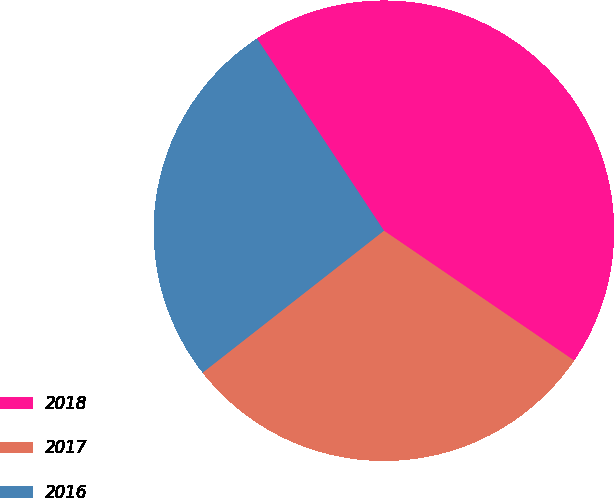Convert chart. <chart><loc_0><loc_0><loc_500><loc_500><pie_chart><fcel>2018<fcel>2017<fcel>2016<nl><fcel>43.83%<fcel>29.9%<fcel>26.28%<nl></chart> 